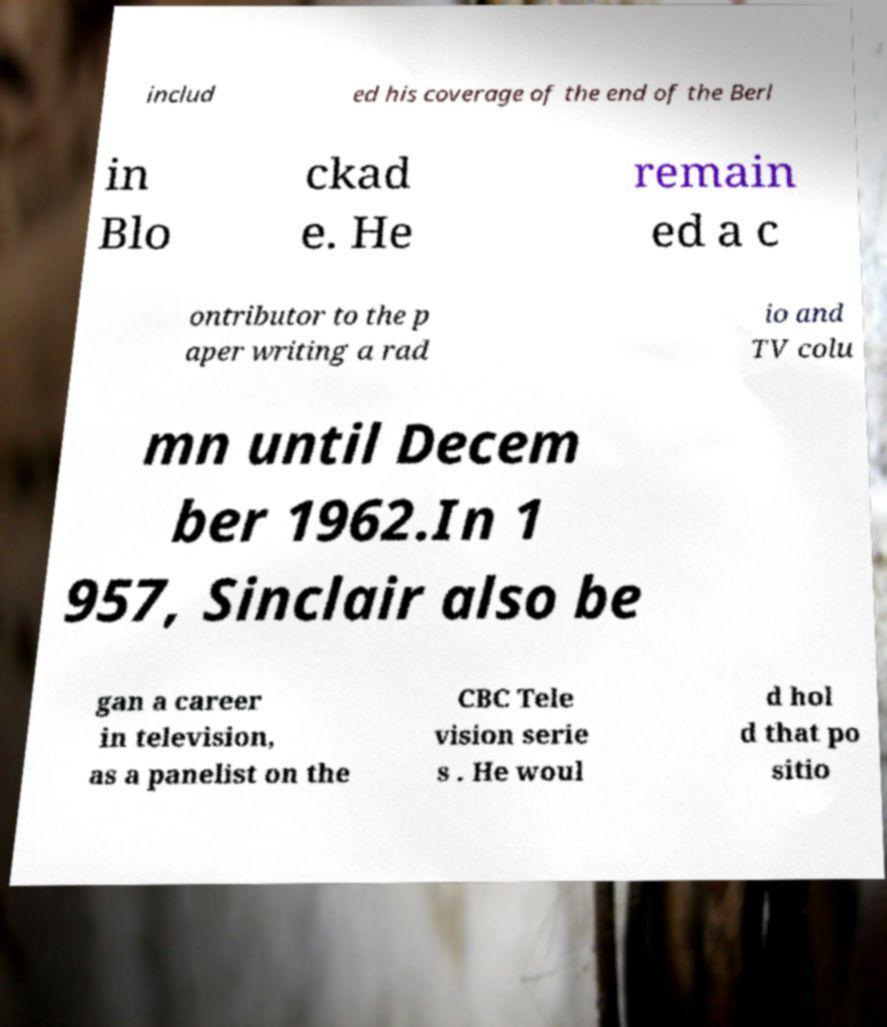I need the written content from this picture converted into text. Can you do that? includ ed his coverage of the end of the Berl in Blo ckad e. He remain ed a c ontributor to the p aper writing a rad io and TV colu mn until Decem ber 1962.In 1 957, Sinclair also be gan a career in television, as a panelist on the CBC Tele vision serie s . He woul d hol d that po sitio 